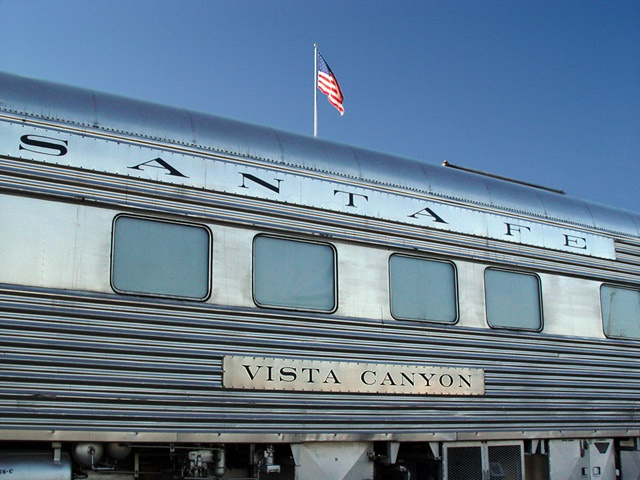Describe the objects in this image and their specific colors. I can see a train in gray, black, and darkgray tones in this image. 